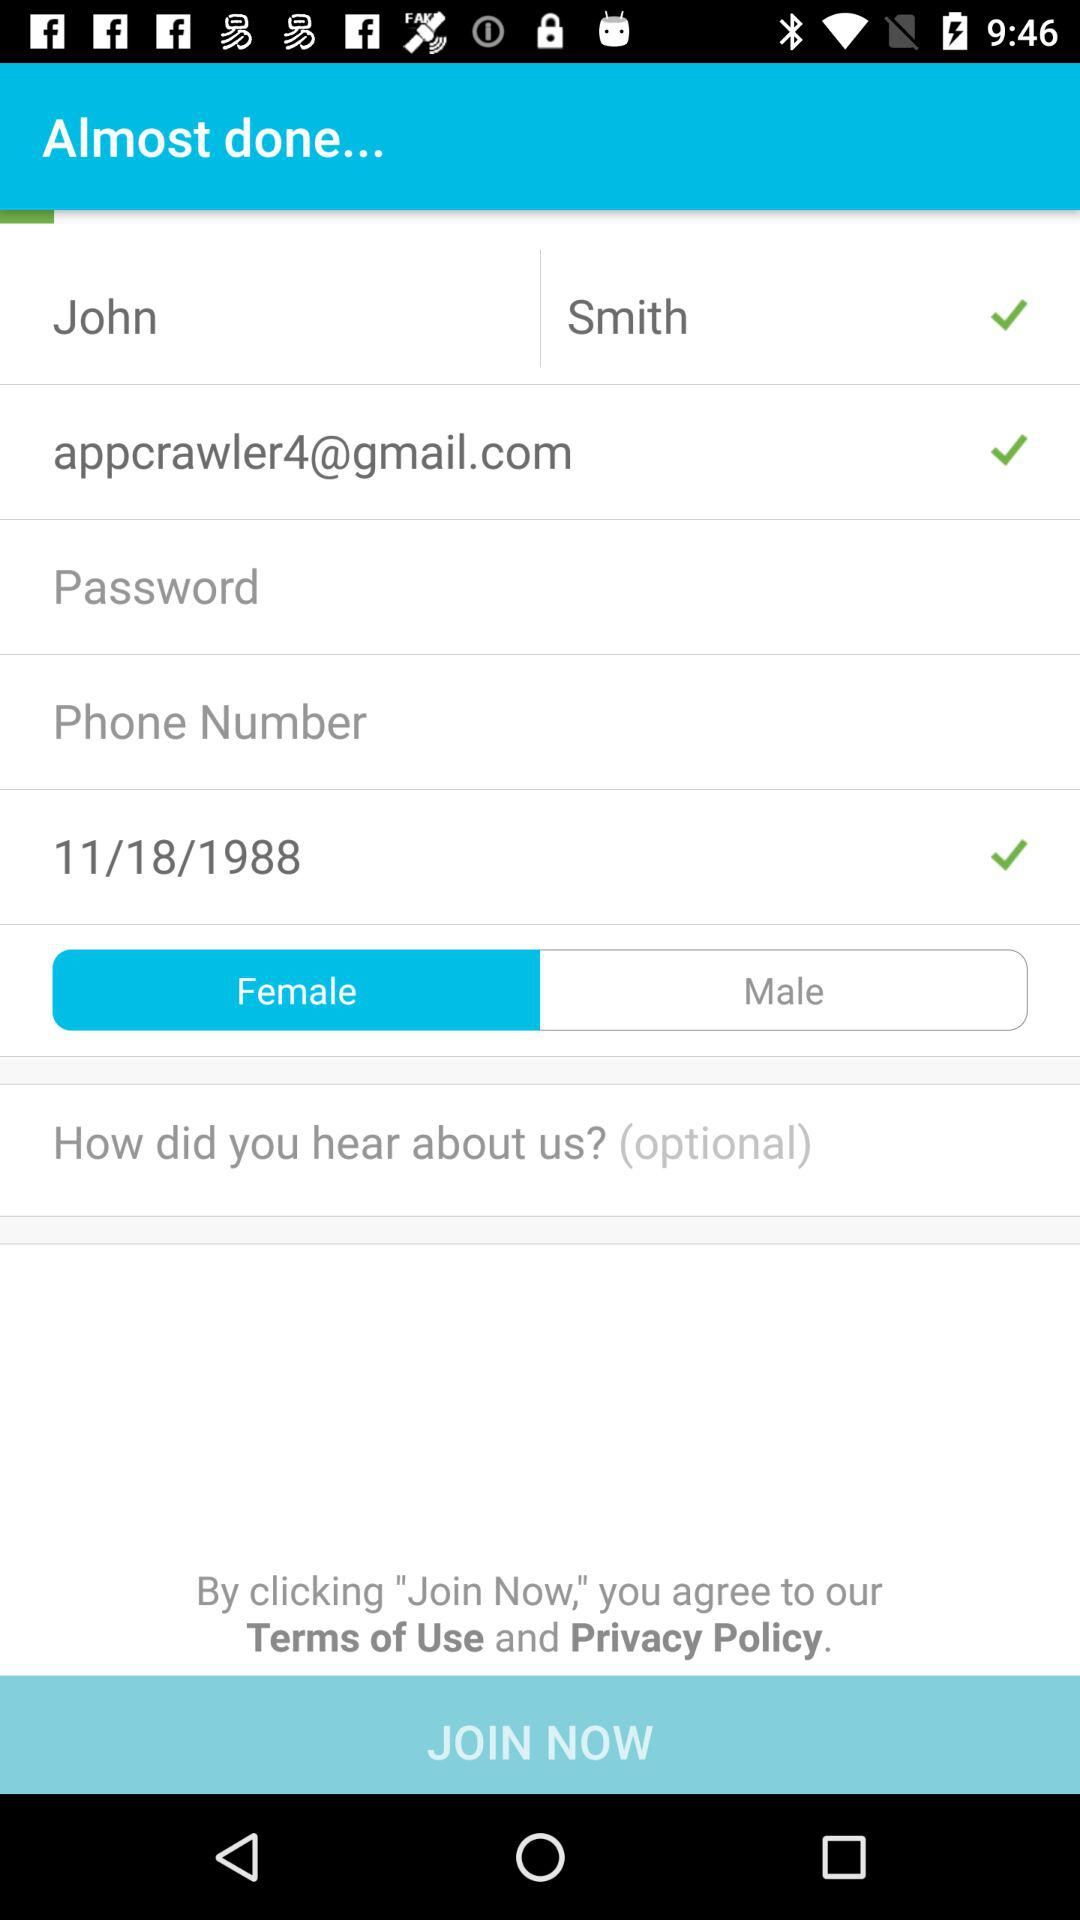What is the name of the user? The name of the user is John Smith. 